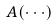<formula> <loc_0><loc_0><loc_500><loc_500>A ( \cdot \cdot \cdot )</formula> 